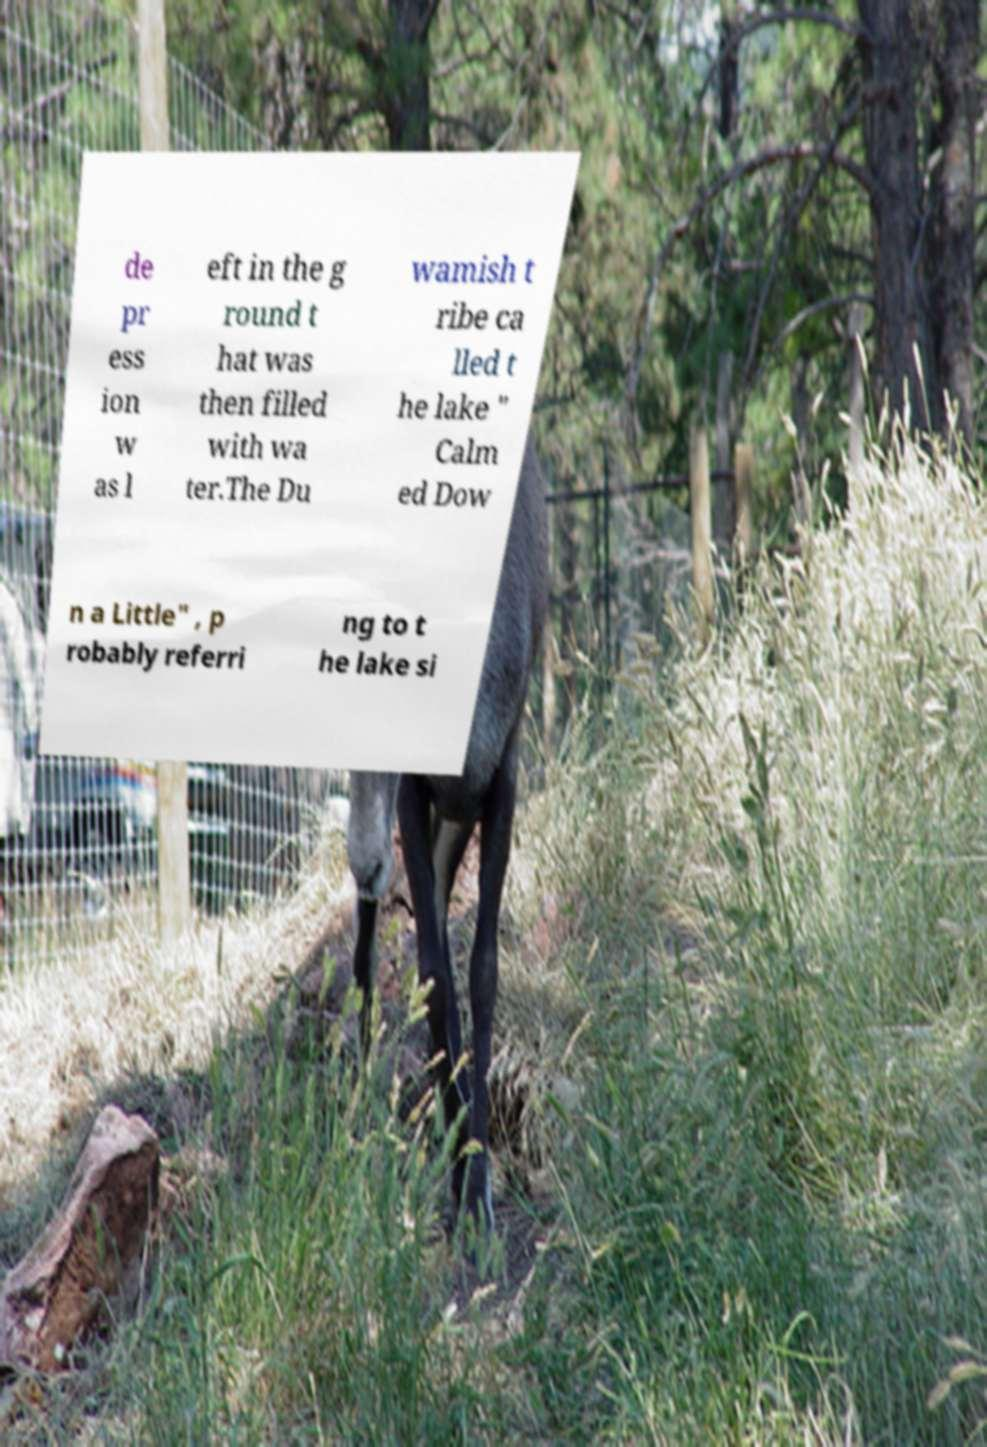Can you accurately transcribe the text from the provided image for me? de pr ess ion w as l eft in the g round t hat was then filled with wa ter.The Du wamish t ribe ca lled t he lake " Calm ed Dow n a Little" , p robably referri ng to t he lake si 